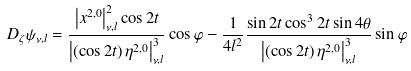<formula> <loc_0><loc_0><loc_500><loc_500>D _ { \zeta } \psi _ { \nu , l } = \frac { \left | x ^ { 2 , 0 } \right | _ { \nu , l } ^ { 2 } \cos 2 t } { \left | \left ( \cos 2 t \right ) \eta ^ { 2 , 0 } \right | _ { \nu , l } ^ { 3 } } \cos \varphi - \frac { 1 } { 4 l ^ { 2 } } \frac { \sin 2 t \cos ^ { 3 } 2 t \sin 4 \theta } { \left | \left ( \cos 2 t \right ) \eta ^ { 2 , 0 } \right | _ { \nu , l } ^ { 3 } } \sin \varphi</formula> 